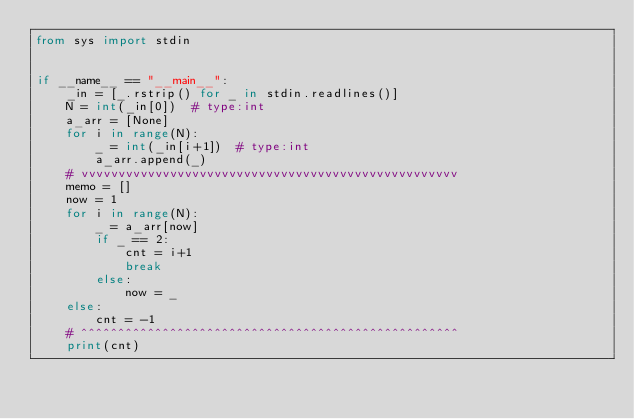<code> <loc_0><loc_0><loc_500><loc_500><_Python_>from sys import stdin


if __name__ == "__main__":
    _in = [_.rstrip() for _ in stdin.readlines()]
    N = int(_in[0])  # type:int
    a_arr = [None]
    for i in range(N):
        _ = int(_in[i+1])  # type:int
        a_arr.append(_)
    # vvvvvvvvvvvvvvvvvvvvvvvvvvvvvvvvvvvvvvvvvvvvvvvvvvv
    memo = []
    now = 1
    for i in range(N):
        _ = a_arr[now]
        if _ == 2:
            cnt = i+1
            break
        else:
            now = _
    else:
        cnt = -1
    # ^^^^^^^^^^^^^^^^^^^^^^^^^^^^^^^^^^^^^^^^^^^^^^^^^^^
    print(cnt)
</code> 